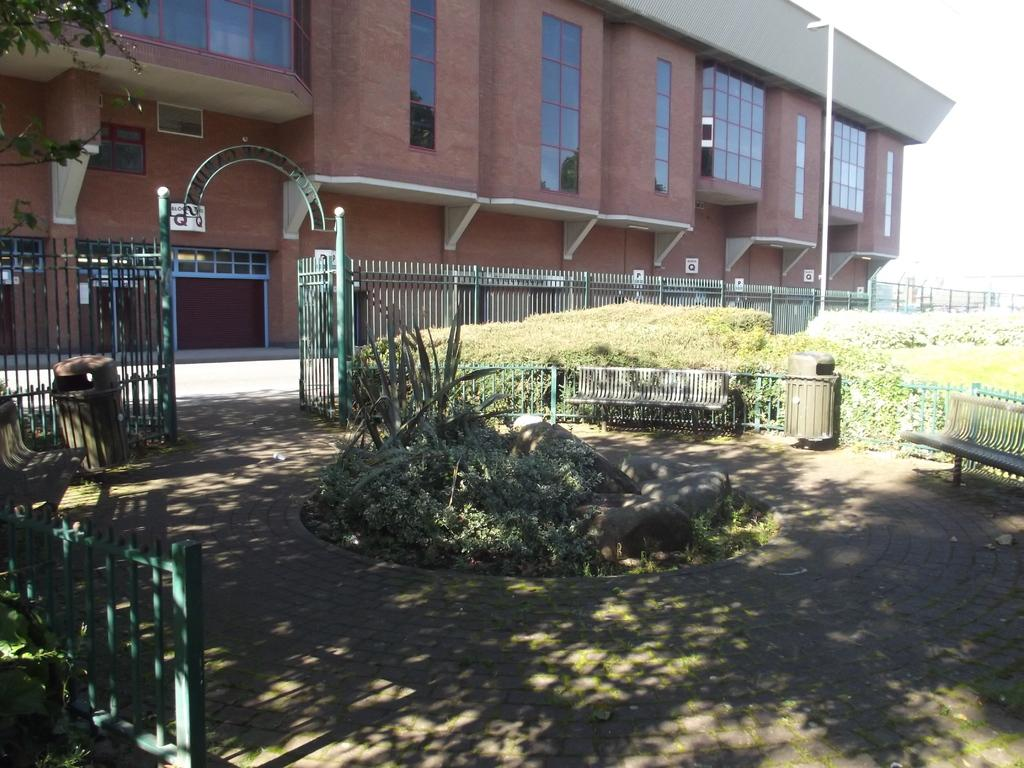What type of seating is available at the bottom of the image? There are sitting benches at the bottom of the image. What material is used to create the fencing on the left side of the image? The fencing on the left side of the image is made up of iron. Can you describe the building in the image? There is a building with glass in the image. How many prisoners are visible in the image? There are no prisoners present in the image. What type of lock is used on the compound fencing in the image? There is no lock visible on the compound fencing in the image. 